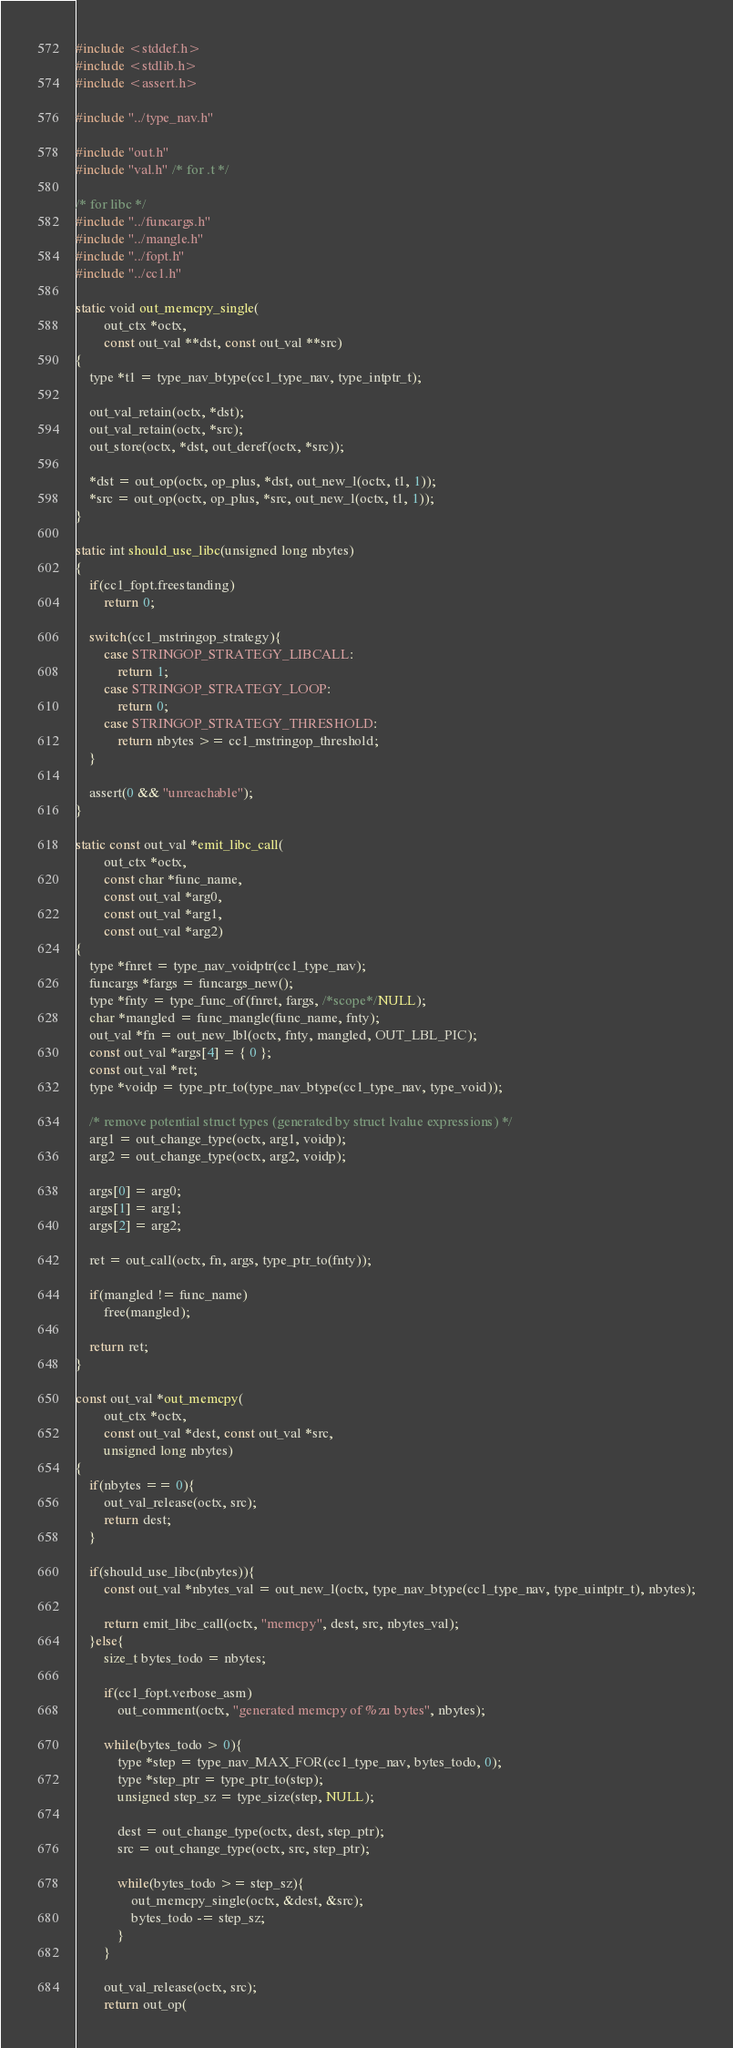Convert code to text. <code><loc_0><loc_0><loc_500><loc_500><_C_>#include <stddef.h>
#include <stdlib.h>
#include <assert.h>

#include "../type_nav.h"

#include "out.h"
#include "val.h" /* for .t */

/* for libc */
#include "../funcargs.h"
#include "../mangle.h"
#include "../fopt.h"
#include "../cc1.h"

static void out_memcpy_single(
		out_ctx *octx,
		const out_val **dst, const out_val **src)
{
	type *t1 = type_nav_btype(cc1_type_nav, type_intptr_t);

	out_val_retain(octx, *dst);
	out_val_retain(octx, *src);
	out_store(octx, *dst, out_deref(octx, *src));

	*dst = out_op(octx, op_plus, *dst, out_new_l(octx, t1, 1));
	*src = out_op(octx, op_plus, *src, out_new_l(octx, t1, 1));
}

static int should_use_libc(unsigned long nbytes)
{
	if(cc1_fopt.freestanding)
		return 0;

	switch(cc1_mstringop_strategy){
		case STRINGOP_STRATEGY_LIBCALL:
			return 1;
		case STRINGOP_STRATEGY_LOOP:
			return 0;
		case STRINGOP_STRATEGY_THRESHOLD:
			return nbytes >= cc1_mstringop_threshold;
	}

	assert(0 && "unreachable");
}

static const out_val *emit_libc_call(
		out_ctx *octx,
		const char *func_name,
		const out_val *arg0,
		const out_val *arg1,
		const out_val *arg2)
{
	type *fnret = type_nav_voidptr(cc1_type_nav);
	funcargs *fargs = funcargs_new();
	type *fnty = type_func_of(fnret, fargs, /*scope*/NULL);
	char *mangled = func_mangle(func_name, fnty);
	out_val *fn = out_new_lbl(octx, fnty, mangled, OUT_LBL_PIC);
	const out_val *args[4] = { 0 };
	const out_val *ret;
	type *voidp = type_ptr_to(type_nav_btype(cc1_type_nav, type_void));

	/* remove potential struct types (generated by struct lvalue expressions) */
	arg1 = out_change_type(octx, arg1, voidp);
	arg2 = out_change_type(octx, arg2, voidp);

	args[0] = arg0;
	args[1] = arg1;
	args[2] = arg2;

	ret = out_call(octx, fn, args, type_ptr_to(fnty));

	if(mangled != func_name)
		free(mangled);

	return ret;
}

const out_val *out_memcpy(
		out_ctx *octx,
		const out_val *dest, const out_val *src,
		unsigned long nbytes)
{
	if(nbytes == 0){
		out_val_release(octx, src);
		return dest;
	}

	if(should_use_libc(nbytes)){
		const out_val *nbytes_val = out_new_l(octx, type_nav_btype(cc1_type_nav, type_uintptr_t), nbytes);

		return emit_libc_call(octx, "memcpy", dest, src, nbytes_val);
	}else{
		size_t bytes_todo = nbytes;

		if(cc1_fopt.verbose_asm)
			out_comment(octx, "generated memcpy of %zu bytes", nbytes);

		while(bytes_todo > 0){
			type *step = type_nav_MAX_FOR(cc1_type_nav, bytes_todo, 0);
			type *step_ptr = type_ptr_to(step);
			unsigned step_sz = type_size(step, NULL);

			dest = out_change_type(octx, dest, step_ptr);
			src = out_change_type(octx, src, step_ptr);

			while(bytes_todo >= step_sz){
				out_memcpy_single(octx, &dest, &src);
				bytes_todo -= step_sz;
			}
		}

		out_val_release(octx, src);
		return out_op(</code> 